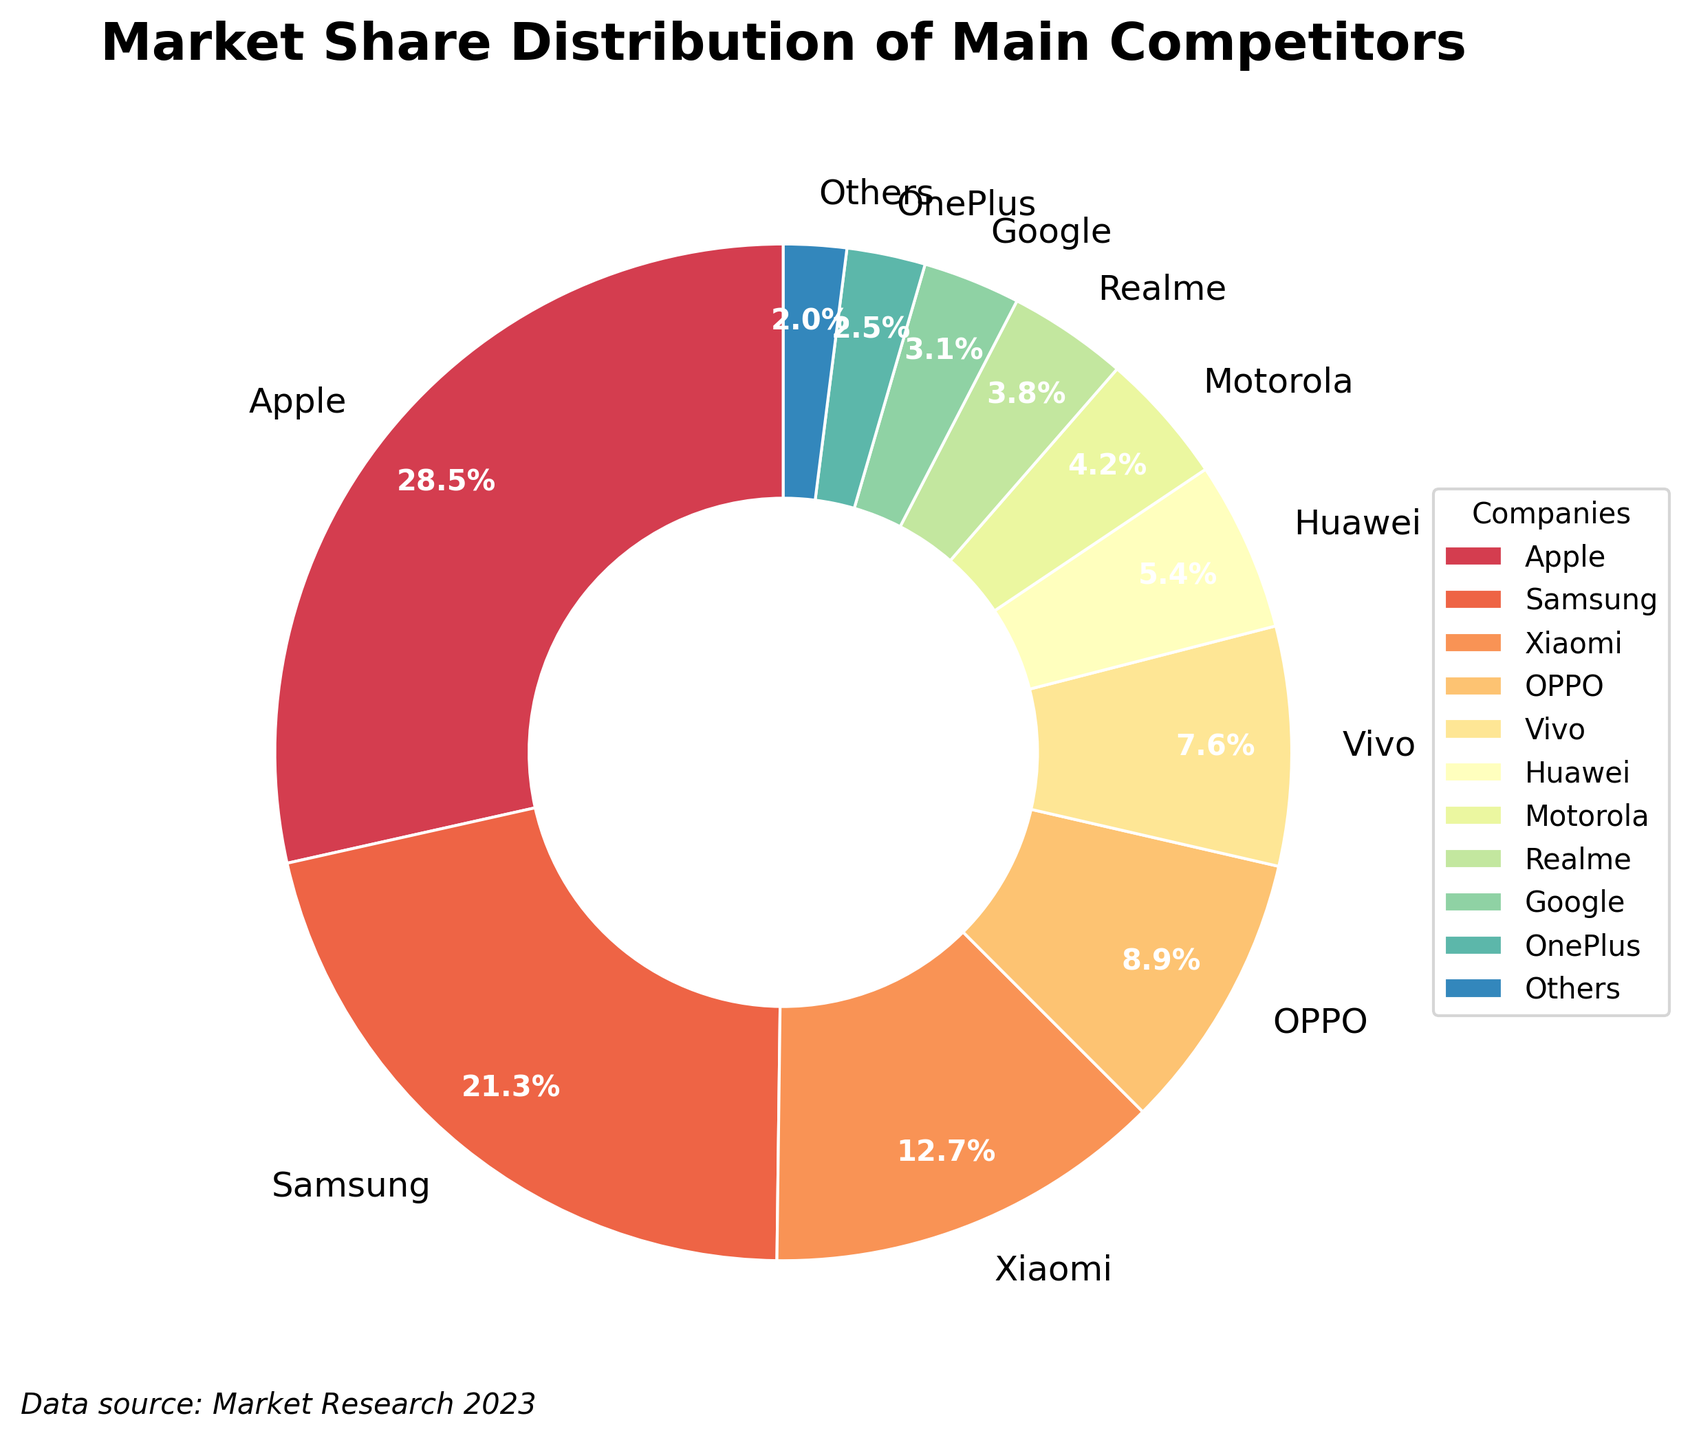What is the company with the largest market share? The largest sector in the pie chart is labeled "Apple." From the figure, it's clear that Apple occupies the largest portion.
Answer: Apple What percentage more market share does Apple have compared to Samsung? From the pie chart, Apple's market share is 28.5% and Samsung's is 21.3%. The difference in percentage is calculated as 28.5 - 21.3.
Answer: 7.2% What's the total market share of companies with less than 5% market share each? The companies with less than 5% market share are Motorola (4.2%), Realme (3.8%), Google (3.1%), OnePlus (2.5%), and Others (2%). Sum these percentages to get the total.
Answer: 15.6% How does the market share of Xiaomi compare to that of OPPO and Vivo combined? Xiaomi's market share is 12.7%. The combined market share of OPPO and Vivo is 8.9% + 7.6% = 16.5%. Since 12.7% is less than 16.5%, Xiaomi's market share is smaller.
Answer: Smaller Which two companies have the closest market shares, and what are their shares? Comparing the market shares, OPPO (8.9%) and Vivo (7.6%) appear to be the closest in value. The difference is 8.9 - 7.6 = 1.3 percentage points.
Answer: OPPO (8.9%) and Vivo (7.6%) What's the combined market share of the top three companies? The top three companies are Apple (28.5%), Samsung (21.3%), and Xiaomi (12.7%). Adding these shares gives 28.5 + 21.3 + 12.7.
Answer: 62.5% Which company has the smallest market share, and what is it? From the pie chart, the smallest market share belongs to "Others," which is labeled as 2%.
Answer: Others, 2% Identify all companies with more than 10% market share. Scan through the pie chart labels and identify companies with more than 10% market share: Apple (28.5%), Samsung (21.3%), and Xiaomi (12.7%).
Answer: Apple, Samsung, Xiaomi What's the difference in market share between the second-largest and fourth-largest companies? The second-largest company is Samsung (21.3%) and the fourth-largest is OPPO (8.9%). The difference is 21.3 - 8.9.
Answer: 12.4% 